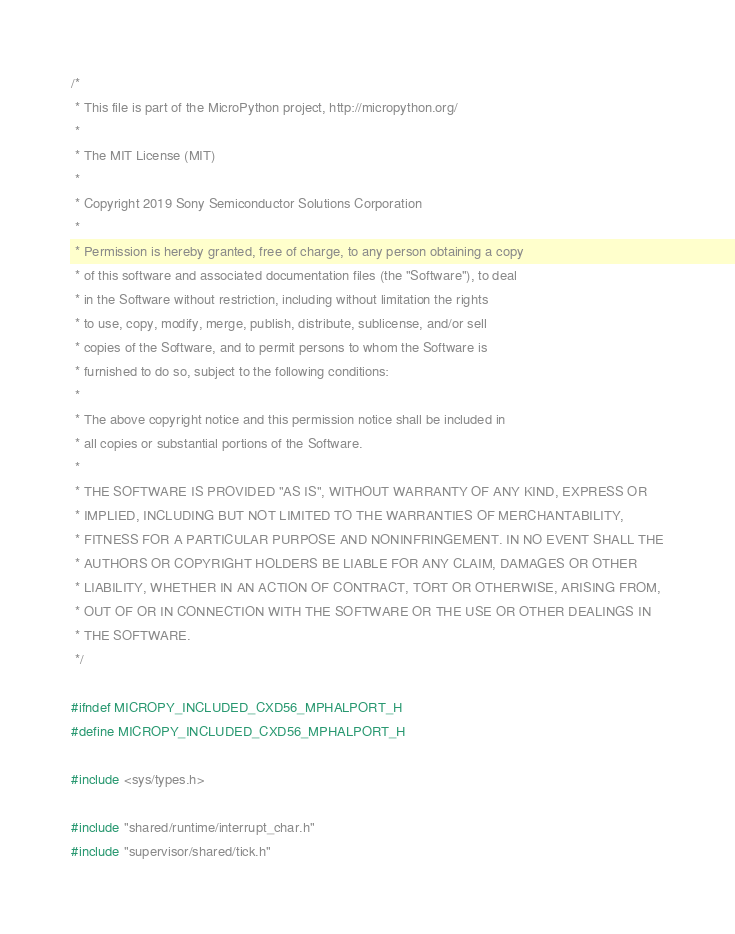<code> <loc_0><loc_0><loc_500><loc_500><_C_>/*
 * This file is part of the MicroPython project, http://micropython.org/
 *
 * The MIT License (MIT)
 *
 * Copyright 2019 Sony Semiconductor Solutions Corporation
 *
 * Permission is hereby granted, free of charge, to any person obtaining a copy
 * of this software and associated documentation files (the "Software"), to deal
 * in the Software without restriction, including without limitation the rights
 * to use, copy, modify, merge, publish, distribute, sublicense, and/or sell
 * copies of the Software, and to permit persons to whom the Software is
 * furnished to do so, subject to the following conditions:
 *
 * The above copyright notice and this permission notice shall be included in
 * all copies or substantial portions of the Software.
 *
 * THE SOFTWARE IS PROVIDED "AS IS", WITHOUT WARRANTY OF ANY KIND, EXPRESS OR
 * IMPLIED, INCLUDING BUT NOT LIMITED TO THE WARRANTIES OF MERCHANTABILITY,
 * FITNESS FOR A PARTICULAR PURPOSE AND NONINFRINGEMENT. IN NO EVENT SHALL THE
 * AUTHORS OR COPYRIGHT HOLDERS BE LIABLE FOR ANY CLAIM, DAMAGES OR OTHER
 * LIABILITY, WHETHER IN AN ACTION OF CONTRACT, TORT OR OTHERWISE, ARISING FROM,
 * OUT OF OR IN CONNECTION WITH THE SOFTWARE OR THE USE OR OTHER DEALINGS IN
 * THE SOFTWARE.
 */

#ifndef MICROPY_INCLUDED_CXD56_MPHALPORT_H
#define MICROPY_INCLUDED_CXD56_MPHALPORT_H

#include <sys/types.h>

#include "shared/runtime/interrupt_char.h"
#include "supervisor/shared/tick.h"
</code> 